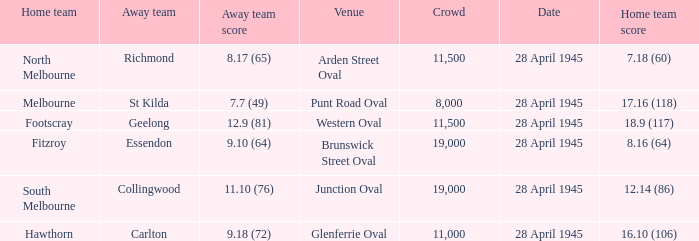Which home team has an Away team of essendon? 8.16 (64). 